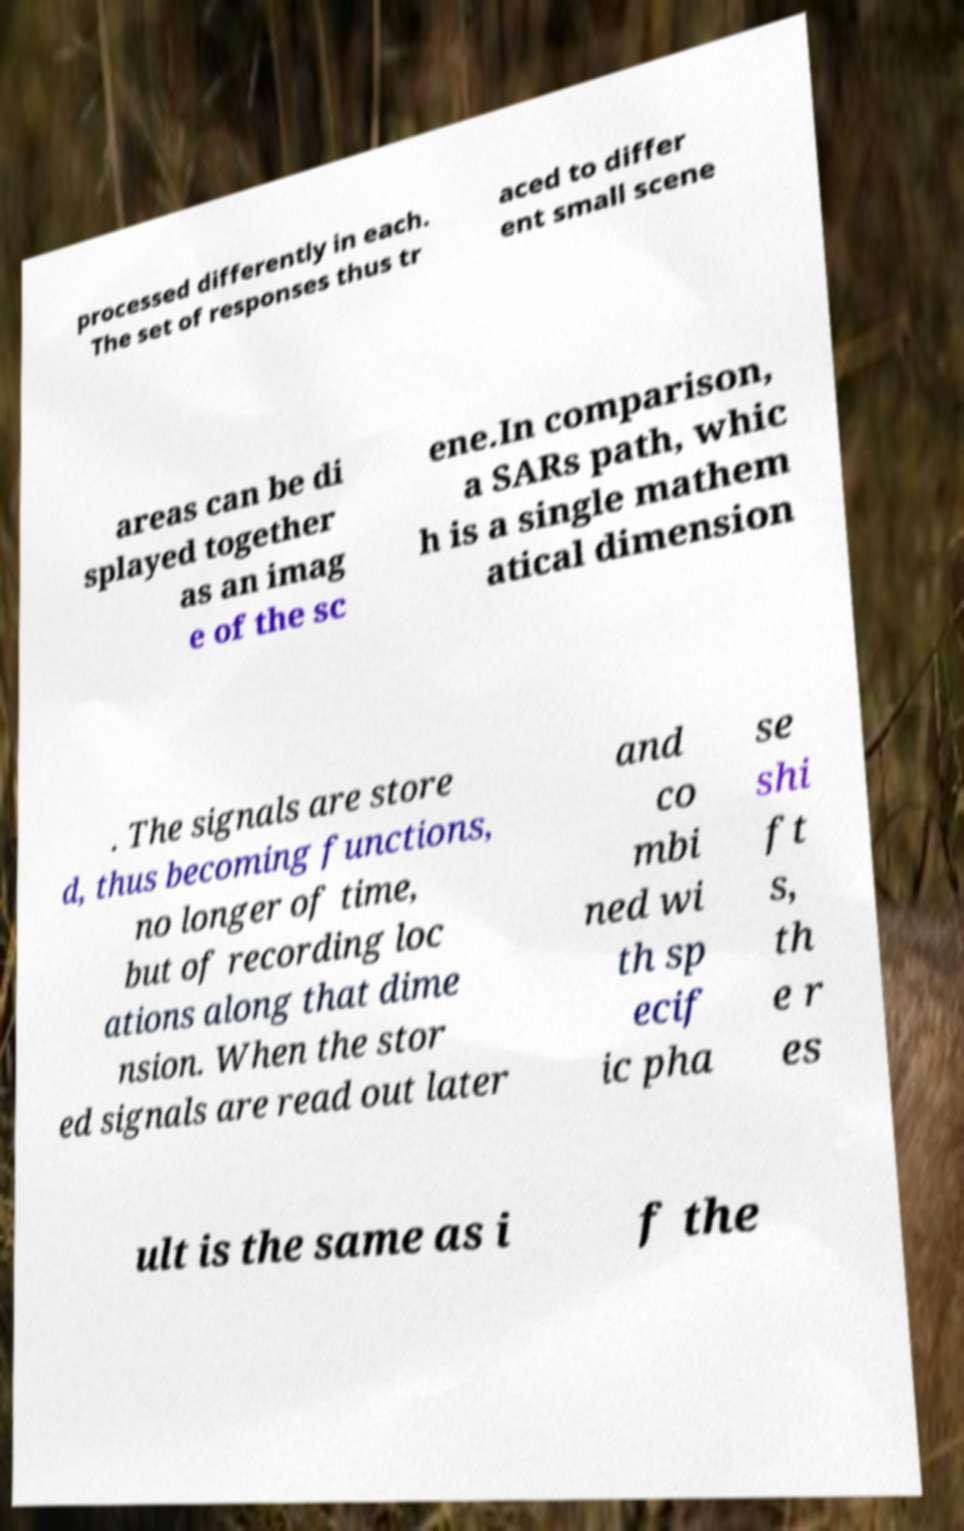I need the written content from this picture converted into text. Can you do that? processed differently in each. The set of responses thus tr aced to differ ent small scene areas can be di splayed together as an imag e of the sc ene.In comparison, a SARs path, whic h is a single mathem atical dimension . The signals are store d, thus becoming functions, no longer of time, but of recording loc ations along that dime nsion. When the stor ed signals are read out later and co mbi ned wi th sp ecif ic pha se shi ft s, th e r es ult is the same as i f the 